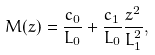Convert formula to latex. <formula><loc_0><loc_0><loc_500><loc_500>M ( z ) = \frac { c _ { 0 } } { L _ { 0 } } + \frac { c _ { 1 } } { L _ { 0 } } \frac { z ^ { 2 } } { L _ { 1 } ^ { 2 } } ,</formula> 